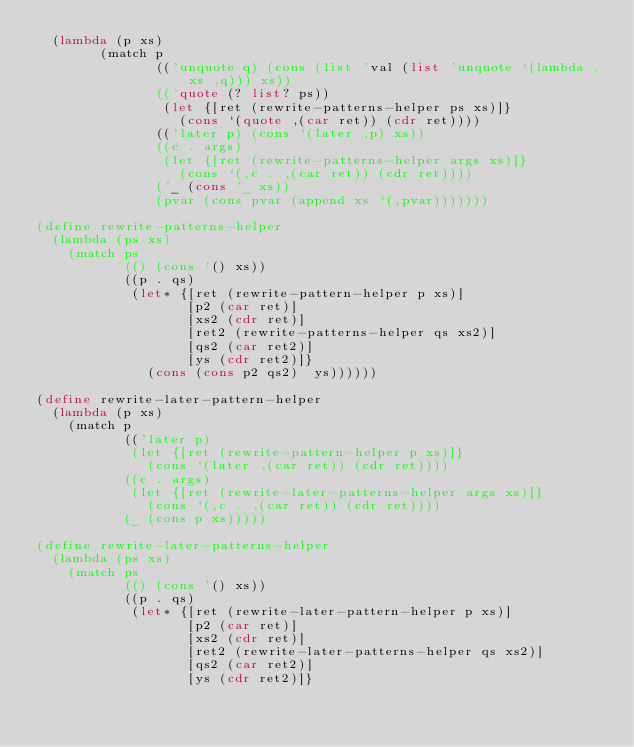<code> <loc_0><loc_0><loc_500><loc_500><_Scheme_>  (lambda (p xs)
        (match p
               (('unquote q) (cons (list 'val (list 'unquote `(lambda ,xs ,q))) xs))
               (('quote (? list? ps))
                (let {[ret (rewrite-patterns-helper ps xs)]}
                  (cons `(quote ,(car ret)) (cdr ret))))
               (('later p) (cons `(later ,p) xs))
               ((c . args)
                (let {[ret (rewrite-patterns-helper args xs)]}
                  (cons `(,c . ,(car ret)) (cdr ret))))
               ('_ (cons '_ xs))
               (pvar (cons pvar (append xs `(,pvar)))))))

(define rewrite-patterns-helper
  (lambda (ps xs)
    (match ps
           (() (cons '() xs))
           ((p . qs)
            (let* {[ret (rewrite-pattern-helper p xs)]
                   [p2 (car ret)]
                   [xs2 (cdr ret)]
                   [ret2 (rewrite-patterns-helper qs xs2)]
                   [qs2 (car ret2)]
                   [ys (cdr ret2)]}
              (cons (cons p2 qs2)  ys))))))

(define rewrite-later-pattern-helper
  (lambda (p xs)
    (match p
           (('later p)
            (let {[ret (rewrite-pattern-helper p xs)]}
              (cons `(later ,(car ret)) (cdr ret))))
           ((c . args)
            (let {[ret (rewrite-later-patterns-helper args xs)]}
              (cons `(,c . ,(car ret)) (cdr ret))))
           (_ (cons p xs)))))

(define rewrite-later-patterns-helper
  (lambda (ps xs)
    (match ps
           (() (cons '() xs))
           ((p . qs)
            (let* {[ret (rewrite-later-pattern-helper p xs)]
                   [p2 (car ret)]
                   [xs2 (cdr ret)]
                   [ret2 (rewrite-later-patterns-helper qs xs2)]
                   [qs2 (car ret2)]
                   [ys (cdr ret2)]}</code> 